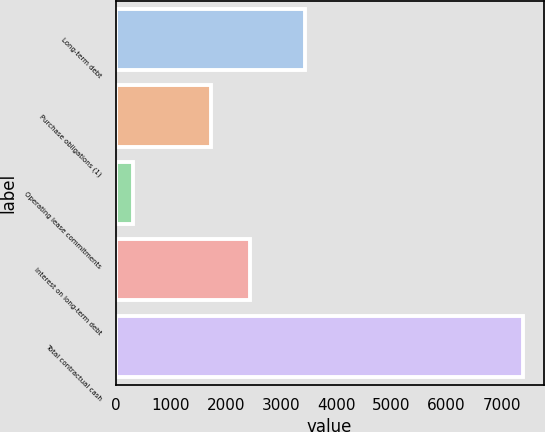Convert chart to OTSL. <chart><loc_0><loc_0><loc_500><loc_500><bar_chart><fcel>Long-term debt<fcel>Purchase obligations (1)<fcel>Operating lease commitments<fcel>Interest on long-term debt<fcel>Total contractual cash<nl><fcel>3443<fcel>1736<fcel>313<fcel>2444.1<fcel>7394<nl></chart> 